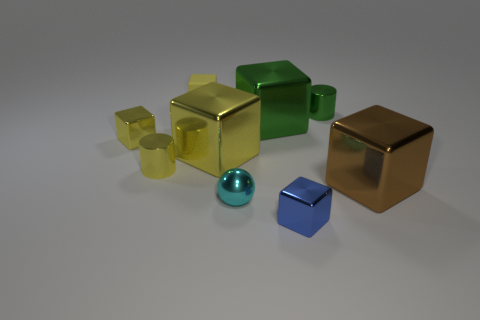Add 1 blocks. How many objects exist? 10 Subtract all large brown blocks. How many blocks are left? 5 Subtract 2 cylinders. How many cylinders are left? 0 Subtract all cylinders. How many objects are left? 7 Subtract all green cubes. How many cubes are left? 5 Subtract all small yellow rubber things. Subtract all large yellow blocks. How many objects are left? 7 Add 5 small cyan metallic objects. How many small cyan metallic objects are left? 6 Add 5 small yellow cylinders. How many small yellow cylinders exist? 6 Subtract 0 yellow balls. How many objects are left? 9 Subtract all brown blocks. Subtract all brown cylinders. How many blocks are left? 5 